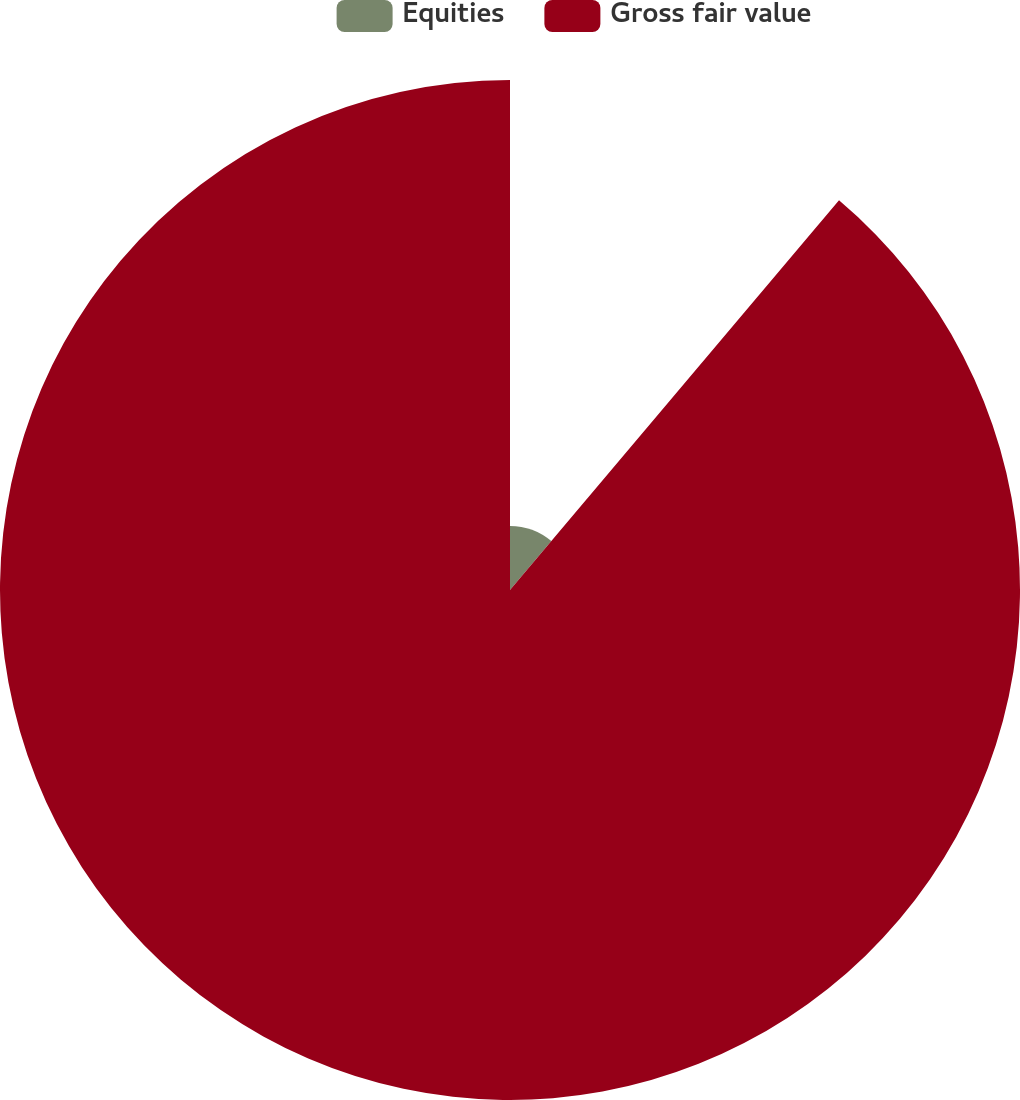<chart> <loc_0><loc_0><loc_500><loc_500><pie_chart><fcel>Equities<fcel>Gross fair value<nl><fcel>11.16%<fcel>88.84%<nl></chart> 